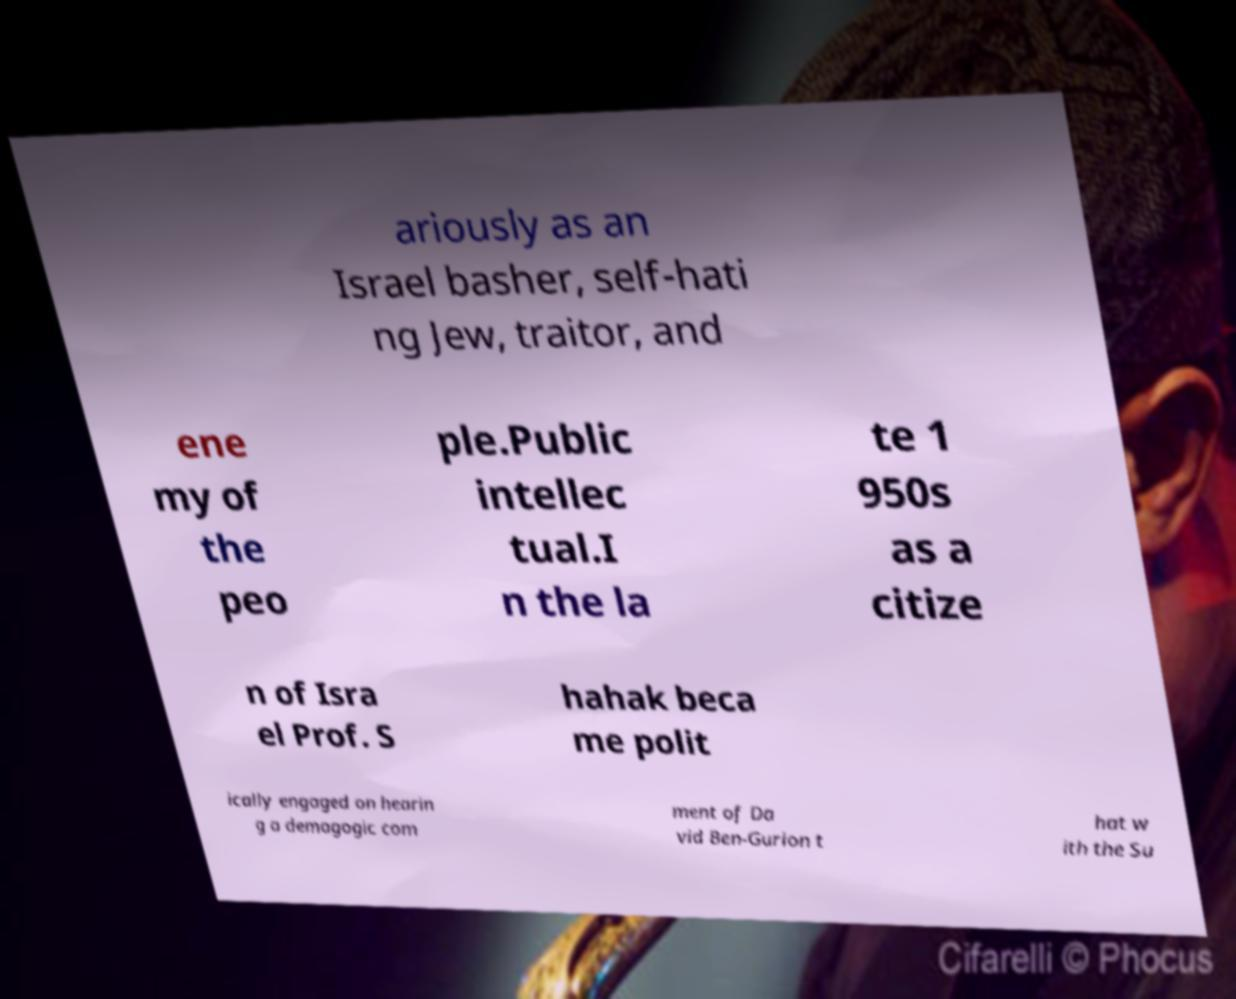What messages or text are displayed in this image? I need them in a readable, typed format. ariously as an Israel basher, self-hati ng Jew, traitor, and ene my of the peo ple.Public intellec tual.I n the la te 1 950s as a citize n of Isra el Prof. S hahak beca me polit ically engaged on hearin g a demagogic com ment of Da vid Ben-Gurion t hat w ith the Su 